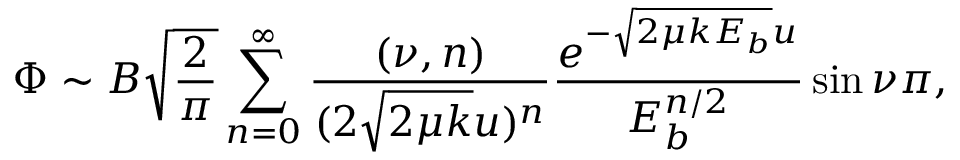Convert formula to latex. <formula><loc_0><loc_0><loc_500><loc_500>\Phi \sim B \sqrt { \frac { 2 } { \pi } } \sum _ { n = 0 } ^ { \infty } \frac { ( \nu , n ) } { ( 2 \sqrt { 2 \mu k } u ) ^ { n } } \frac { e ^ { - \sqrt { 2 \mu k E _ { b } } u } } { E _ { b } ^ { n / 2 } } \sin { \nu \pi } ,</formula> 